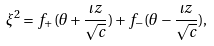<formula> <loc_0><loc_0><loc_500><loc_500>\xi ^ { 2 } = f _ { + } ( \theta + \frac { \iota z } { \sqrt { c } } ) + f _ { - } ( \theta - \frac { \iota z } { \sqrt { c } } ) ,</formula> 